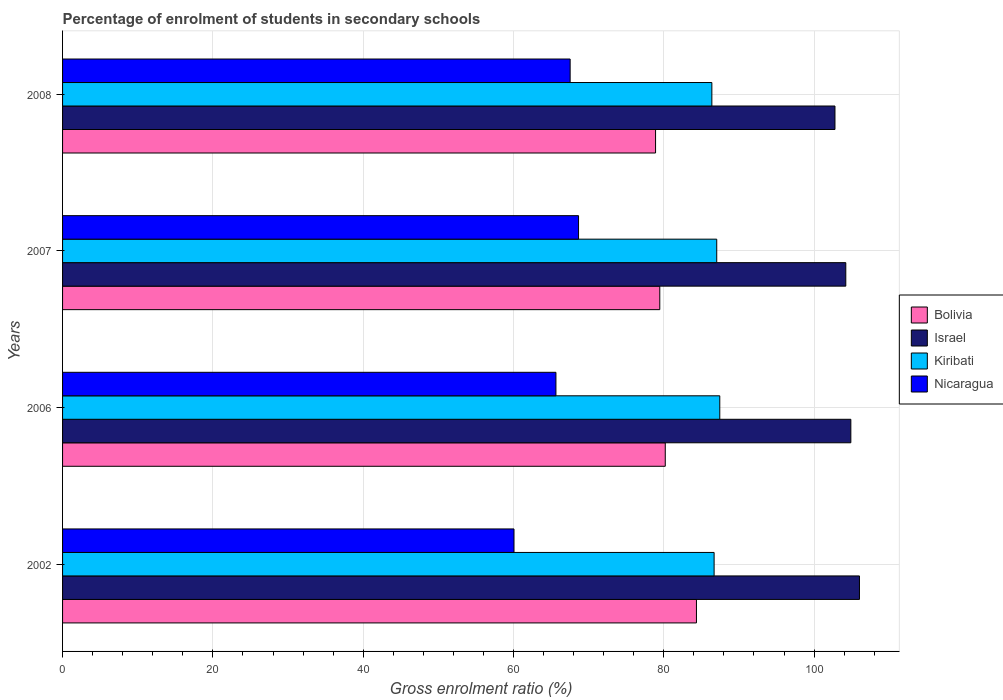Are the number of bars on each tick of the Y-axis equal?
Your answer should be very brief. Yes. What is the label of the 4th group of bars from the top?
Offer a very short reply. 2002. In how many cases, is the number of bars for a given year not equal to the number of legend labels?
Keep it short and to the point. 0. What is the percentage of students enrolled in secondary schools in Nicaragua in 2007?
Give a very brief answer. 68.66. Across all years, what is the maximum percentage of students enrolled in secondary schools in Bolivia?
Ensure brevity in your answer.  84.34. Across all years, what is the minimum percentage of students enrolled in secondary schools in Nicaragua?
Ensure brevity in your answer.  60.07. In which year was the percentage of students enrolled in secondary schools in Israel minimum?
Ensure brevity in your answer.  2008. What is the total percentage of students enrolled in secondary schools in Kiribati in the graph?
Make the answer very short. 347.58. What is the difference between the percentage of students enrolled in secondary schools in Bolivia in 2006 and that in 2007?
Ensure brevity in your answer.  0.73. What is the difference between the percentage of students enrolled in secondary schools in Bolivia in 2008 and the percentage of students enrolled in secondary schools in Nicaragua in 2007?
Make the answer very short. 10.25. What is the average percentage of students enrolled in secondary schools in Bolivia per year?
Provide a succinct answer. 80.73. In the year 2008, what is the difference between the percentage of students enrolled in secondary schools in Nicaragua and percentage of students enrolled in secondary schools in Kiribati?
Make the answer very short. -18.86. In how many years, is the percentage of students enrolled in secondary schools in Nicaragua greater than 52 %?
Offer a terse response. 4. What is the ratio of the percentage of students enrolled in secondary schools in Bolivia in 2002 to that in 2008?
Give a very brief answer. 1.07. Is the percentage of students enrolled in secondary schools in Nicaragua in 2006 less than that in 2007?
Your answer should be very brief. Yes. What is the difference between the highest and the second highest percentage of students enrolled in secondary schools in Israel?
Your answer should be very brief. 1.15. What is the difference between the highest and the lowest percentage of students enrolled in secondary schools in Israel?
Ensure brevity in your answer.  3.26. In how many years, is the percentage of students enrolled in secondary schools in Nicaragua greater than the average percentage of students enrolled in secondary schools in Nicaragua taken over all years?
Your answer should be very brief. 3. Is the sum of the percentage of students enrolled in secondary schools in Bolivia in 2007 and 2008 greater than the maximum percentage of students enrolled in secondary schools in Nicaragua across all years?
Your response must be concise. Yes. What does the 2nd bar from the top in 2006 represents?
Keep it short and to the point. Kiribati. What does the 4th bar from the bottom in 2008 represents?
Your answer should be very brief. Nicaragua. Is it the case that in every year, the sum of the percentage of students enrolled in secondary schools in Israel and percentage of students enrolled in secondary schools in Nicaragua is greater than the percentage of students enrolled in secondary schools in Kiribati?
Provide a succinct answer. Yes. How many bars are there?
Your response must be concise. 16. How many years are there in the graph?
Your answer should be compact. 4. Does the graph contain grids?
Keep it short and to the point. Yes. How many legend labels are there?
Your answer should be compact. 4. How are the legend labels stacked?
Provide a succinct answer. Vertical. What is the title of the graph?
Provide a succinct answer. Percentage of enrolment of students in secondary schools. Does "Guatemala" appear as one of the legend labels in the graph?
Give a very brief answer. No. What is the label or title of the X-axis?
Your answer should be very brief. Gross enrolment ratio (%). What is the label or title of the Y-axis?
Provide a short and direct response. Years. What is the Gross enrolment ratio (%) of Bolivia in 2002?
Ensure brevity in your answer.  84.34. What is the Gross enrolment ratio (%) of Israel in 2002?
Ensure brevity in your answer.  106.04. What is the Gross enrolment ratio (%) of Kiribati in 2002?
Your answer should be very brief. 86.69. What is the Gross enrolment ratio (%) in Nicaragua in 2002?
Make the answer very short. 60.07. What is the Gross enrolment ratio (%) of Bolivia in 2006?
Your answer should be compact. 80.2. What is the Gross enrolment ratio (%) in Israel in 2006?
Your answer should be compact. 104.89. What is the Gross enrolment ratio (%) in Kiribati in 2006?
Make the answer very short. 87.45. What is the Gross enrolment ratio (%) in Nicaragua in 2006?
Provide a short and direct response. 65.65. What is the Gross enrolment ratio (%) in Bolivia in 2007?
Make the answer very short. 79.47. What is the Gross enrolment ratio (%) in Israel in 2007?
Provide a succinct answer. 104.22. What is the Gross enrolment ratio (%) in Kiribati in 2007?
Give a very brief answer. 87.04. What is the Gross enrolment ratio (%) in Nicaragua in 2007?
Your answer should be very brief. 68.66. What is the Gross enrolment ratio (%) in Bolivia in 2008?
Make the answer very short. 78.9. What is the Gross enrolment ratio (%) in Israel in 2008?
Keep it short and to the point. 102.78. What is the Gross enrolment ratio (%) in Kiribati in 2008?
Offer a very short reply. 86.4. What is the Gross enrolment ratio (%) in Nicaragua in 2008?
Give a very brief answer. 67.54. Across all years, what is the maximum Gross enrolment ratio (%) in Bolivia?
Make the answer very short. 84.34. Across all years, what is the maximum Gross enrolment ratio (%) of Israel?
Provide a short and direct response. 106.04. Across all years, what is the maximum Gross enrolment ratio (%) of Kiribati?
Give a very brief answer. 87.45. Across all years, what is the maximum Gross enrolment ratio (%) in Nicaragua?
Keep it short and to the point. 68.66. Across all years, what is the minimum Gross enrolment ratio (%) in Bolivia?
Ensure brevity in your answer.  78.9. Across all years, what is the minimum Gross enrolment ratio (%) of Israel?
Give a very brief answer. 102.78. Across all years, what is the minimum Gross enrolment ratio (%) in Kiribati?
Your response must be concise. 86.4. Across all years, what is the minimum Gross enrolment ratio (%) of Nicaragua?
Provide a short and direct response. 60.07. What is the total Gross enrolment ratio (%) of Bolivia in the graph?
Your answer should be compact. 322.91. What is the total Gross enrolment ratio (%) of Israel in the graph?
Make the answer very short. 417.92. What is the total Gross enrolment ratio (%) in Kiribati in the graph?
Ensure brevity in your answer.  347.58. What is the total Gross enrolment ratio (%) in Nicaragua in the graph?
Ensure brevity in your answer.  261.91. What is the difference between the Gross enrolment ratio (%) of Bolivia in 2002 and that in 2006?
Keep it short and to the point. 4.15. What is the difference between the Gross enrolment ratio (%) of Israel in 2002 and that in 2006?
Your response must be concise. 1.15. What is the difference between the Gross enrolment ratio (%) in Kiribati in 2002 and that in 2006?
Ensure brevity in your answer.  -0.75. What is the difference between the Gross enrolment ratio (%) of Nicaragua in 2002 and that in 2006?
Your answer should be very brief. -5.58. What is the difference between the Gross enrolment ratio (%) in Bolivia in 2002 and that in 2007?
Your response must be concise. 4.88. What is the difference between the Gross enrolment ratio (%) in Israel in 2002 and that in 2007?
Ensure brevity in your answer.  1.82. What is the difference between the Gross enrolment ratio (%) of Kiribati in 2002 and that in 2007?
Make the answer very short. -0.35. What is the difference between the Gross enrolment ratio (%) of Nicaragua in 2002 and that in 2007?
Your response must be concise. -8.59. What is the difference between the Gross enrolment ratio (%) in Bolivia in 2002 and that in 2008?
Your response must be concise. 5.44. What is the difference between the Gross enrolment ratio (%) in Israel in 2002 and that in 2008?
Your answer should be compact. 3.26. What is the difference between the Gross enrolment ratio (%) of Kiribati in 2002 and that in 2008?
Provide a short and direct response. 0.3. What is the difference between the Gross enrolment ratio (%) in Nicaragua in 2002 and that in 2008?
Give a very brief answer. -7.47. What is the difference between the Gross enrolment ratio (%) in Bolivia in 2006 and that in 2007?
Ensure brevity in your answer.  0.73. What is the difference between the Gross enrolment ratio (%) in Israel in 2006 and that in 2007?
Provide a succinct answer. 0.67. What is the difference between the Gross enrolment ratio (%) in Kiribati in 2006 and that in 2007?
Offer a terse response. 0.41. What is the difference between the Gross enrolment ratio (%) in Nicaragua in 2006 and that in 2007?
Your answer should be very brief. -3.01. What is the difference between the Gross enrolment ratio (%) in Bolivia in 2006 and that in 2008?
Your response must be concise. 1.29. What is the difference between the Gross enrolment ratio (%) of Israel in 2006 and that in 2008?
Keep it short and to the point. 2.11. What is the difference between the Gross enrolment ratio (%) of Kiribati in 2006 and that in 2008?
Give a very brief answer. 1.05. What is the difference between the Gross enrolment ratio (%) of Nicaragua in 2006 and that in 2008?
Make the answer very short. -1.89. What is the difference between the Gross enrolment ratio (%) in Bolivia in 2007 and that in 2008?
Ensure brevity in your answer.  0.56. What is the difference between the Gross enrolment ratio (%) of Israel in 2007 and that in 2008?
Keep it short and to the point. 1.44. What is the difference between the Gross enrolment ratio (%) of Kiribati in 2007 and that in 2008?
Provide a short and direct response. 0.65. What is the difference between the Gross enrolment ratio (%) in Nicaragua in 2007 and that in 2008?
Offer a terse response. 1.12. What is the difference between the Gross enrolment ratio (%) of Bolivia in 2002 and the Gross enrolment ratio (%) of Israel in 2006?
Provide a short and direct response. -20.54. What is the difference between the Gross enrolment ratio (%) of Bolivia in 2002 and the Gross enrolment ratio (%) of Kiribati in 2006?
Provide a short and direct response. -3.1. What is the difference between the Gross enrolment ratio (%) of Bolivia in 2002 and the Gross enrolment ratio (%) of Nicaragua in 2006?
Make the answer very short. 18.7. What is the difference between the Gross enrolment ratio (%) in Israel in 2002 and the Gross enrolment ratio (%) in Kiribati in 2006?
Offer a very short reply. 18.59. What is the difference between the Gross enrolment ratio (%) in Israel in 2002 and the Gross enrolment ratio (%) in Nicaragua in 2006?
Provide a succinct answer. 40.39. What is the difference between the Gross enrolment ratio (%) of Kiribati in 2002 and the Gross enrolment ratio (%) of Nicaragua in 2006?
Provide a succinct answer. 21.05. What is the difference between the Gross enrolment ratio (%) of Bolivia in 2002 and the Gross enrolment ratio (%) of Israel in 2007?
Give a very brief answer. -19.87. What is the difference between the Gross enrolment ratio (%) of Bolivia in 2002 and the Gross enrolment ratio (%) of Kiribati in 2007?
Your answer should be compact. -2.7. What is the difference between the Gross enrolment ratio (%) of Bolivia in 2002 and the Gross enrolment ratio (%) of Nicaragua in 2007?
Provide a succinct answer. 15.69. What is the difference between the Gross enrolment ratio (%) of Israel in 2002 and the Gross enrolment ratio (%) of Kiribati in 2007?
Provide a short and direct response. 18.99. What is the difference between the Gross enrolment ratio (%) of Israel in 2002 and the Gross enrolment ratio (%) of Nicaragua in 2007?
Make the answer very short. 37.38. What is the difference between the Gross enrolment ratio (%) of Kiribati in 2002 and the Gross enrolment ratio (%) of Nicaragua in 2007?
Provide a short and direct response. 18.04. What is the difference between the Gross enrolment ratio (%) of Bolivia in 2002 and the Gross enrolment ratio (%) of Israel in 2008?
Your response must be concise. -18.43. What is the difference between the Gross enrolment ratio (%) of Bolivia in 2002 and the Gross enrolment ratio (%) of Kiribati in 2008?
Offer a terse response. -2.05. What is the difference between the Gross enrolment ratio (%) in Bolivia in 2002 and the Gross enrolment ratio (%) in Nicaragua in 2008?
Provide a succinct answer. 16.81. What is the difference between the Gross enrolment ratio (%) in Israel in 2002 and the Gross enrolment ratio (%) in Kiribati in 2008?
Your answer should be compact. 19.64. What is the difference between the Gross enrolment ratio (%) of Israel in 2002 and the Gross enrolment ratio (%) of Nicaragua in 2008?
Provide a short and direct response. 38.5. What is the difference between the Gross enrolment ratio (%) in Kiribati in 2002 and the Gross enrolment ratio (%) in Nicaragua in 2008?
Your answer should be very brief. 19.16. What is the difference between the Gross enrolment ratio (%) of Bolivia in 2006 and the Gross enrolment ratio (%) of Israel in 2007?
Your answer should be very brief. -24.02. What is the difference between the Gross enrolment ratio (%) in Bolivia in 2006 and the Gross enrolment ratio (%) in Kiribati in 2007?
Ensure brevity in your answer.  -6.85. What is the difference between the Gross enrolment ratio (%) of Bolivia in 2006 and the Gross enrolment ratio (%) of Nicaragua in 2007?
Keep it short and to the point. 11.54. What is the difference between the Gross enrolment ratio (%) of Israel in 2006 and the Gross enrolment ratio (%) of Kiribati in 2007?
Offer a terse response. 17.84. What is the difference between the Gross enrolment ratio (%) in Israel in 2006 and the Gross enrolment ratio (%) in Nicaragua in 2007?
Keep it short and to the point. 36.23. What is the difference between the Gross enrolment ratio (%) in Kiribati in 2006 and the Gross enrolment ratio (%) in Nicaragua in 2007?
Provide a succinct answer. 18.79. What is the difference between the Gross enrolment ratio (%) in Bolivia in 2006 and the Gross enrolment ratio (%) in Israel in 2008?
Offer a terse response. -22.58. What is the difference between the Gross enrolment ratio (%) of Bolivia in 2006 and the Gross enrolment ratio (%) of Kiribati in 2008?
Offer a terse response. -6.2. What is the difference between the Gross enrolment ratio (%) of Bolivia in 2006 and the Gross enrolment ratio (%) of Nicaragua in 2008?
Offer a very short reply. 12.66. What is the difference between the Gross enrolment ratio (%) in Israel in 2006 and the Gross enrolment ratio (%) in Kiribati in 2008?
Give a very brief answer. 18.49. What is the difference between the Gross enrolment ratio (%) of Israel in 2006 and the Gross enrolment ratio (%) of Nicaragua in 2008?
Make the answer very short. 37.35. What is the difference between the Gross enrolment ratio (%) of Kiribati in 2006 and the Gross enrolment ratio (%) of Nicaragua in 2008?
Ensure brevity in your answer.  19.91. What is the difference between the Gross enrolment ratio (%) of Bolivia in 2007 and the Gross enrolment ratio (%) of Israel in 2008?
Provide a short and direct response. -23.31. What is the difference between the Gross enrolment ratio (%) in Bolivia in 2007 and the Gross enrolment ratio (%) in Kiribati in 2008?
Give a very brief answer. -6.93. What is the difference between the Gross enrolment ratio (%) in Bolivia in 2007 and the Gross enrolment ratio (%) in Nicaragua in 2008?
Your answer should be very brief. 11.93. What is the difference between the Gross enrolment ratio (%) in Israel in 2007 and the Gross enrolment ratio (%) in Kiribati in 2008?
Provide a short and direct response. 17.82. What is the difference between the Gross enrolment ratio (%) in Israel in 2007 and the Gross enrolment ratio (%) in Nicaragua in 2008?
Provide a short and direct response. 36.68. What is the difference between the Gross enrolment ratio (%) of Kiribati in 2007 and the Gross enrolment ratio (%) of Nicaragua in 2008?
Make the answer very short. 19.51. What is the average Gross enrolment ratio (%) of Bolivia per year?
Offer a terse response. 80.73. What is the average Gross enrolment ratio (%) of Israel per year?
Offer a very short reply. 104.48. What is the average Gross enrolment ratio (%) of Kiribati per year?
Your response must be concise. 86.9. What is the average Gross enrolment ratio (%) of Nicaragua per year?
Offer a very short reply. 65.48. In the year 2002, what is the difference between the Gross enrolment ratio (%) of Bolivia and Gross enrolment ratio (%) of Israel?
Offer a very short reply. -21.69. In the year 2002, what is the difference between the Gross enrolment ratio (%) of Bolivia and Gross enrolment ratio (%) of Kiribati?
Offer a terse response. -2.35. In the year 2002, what is the difference between the Gross enrolment ratio (%) in Bolivia and Gross enrolment ratio (%) in Nicaragua?
Your answer should be compact. 24.28. In the year 2002, what is the difference between the Gross enrolment ratio (%) in Israel and Gross enrolment ratio (%) in Kiribati?
Offer a terse response. 19.34. In the year 2002, what is the difference between the Gross enrolment ratio (%) of Israel and Gross enrolment ratio (%) of Nicaragua?
Give a very brief answer. 45.97. In the year 2002, what is the difference between the Gross enrolment ratio (%) in Kiribati and Gross enrolment ratio (%) in Nicaragua?
Offer a very short reply. 26.63. In the year 2006, what is the difference between the Gross enrolment ratio (%) of Bolivia and Gross enrolment ratio (%) of Israel?
Make the answer very short. -24.69. In the year 2006, what is the difference between the Gross enrolment ratio (%) in Bolivia and Gross enrolment ratio (%) in Kiribati?
Provide a succinct answer. -7.25. In the year 2006, what is the difference between the Gross enrolment ratio (%) of Bolivia and Gross enrolment ratio (%) of Nicaragua?
Your answer should be very brief. 14.55. In the year 2006, what is the difference between the Gross enrolment ratio (%) in Israel and Gross enrolment ratio (%) in Kiribati?
Your answer should be compact. 17.44. In the year 2006, what is the difference between the Gross enrolment ratio (%) in Israel and Gross enrolment ratio (%) in Nicaragua?
Offer a very short reply. 39.24. In the year 2006, what is the difference between the Gross enrolment ratio (%) of Kiribati and Gross enrolment ratio (%) of Nicaragua?
Your answer should be compact. 21.8. In the year 2007, what is the difference between the Gross enrolment ratio (%) of Bolivia and Gross enrolment ratio (%) of Israel?
Provide a short and direct response. -24.75. In the year 2007, what is the difference between the Gross enrolment ratio (%) in Bolivia and Gross enrolment ratio (%) in Kiribati?
Keep it short and to the point. -7.58. In the year 2007, what is the difference between the Gross enrolment ratio (%) of Bolivia and Gross enrolment ratio (%) of Nicaragua?
Ensure brevity in your answer.  10.81. In the year 2007, what is the difference between the Gross enrolment ratio (%) of Israel and Gross enrolment ratio (%) of Kiribati?
Your answer should be compact. 17.17. In the year 2007, what is the difference between the Gross enrolment ratio (%) of Israel and Gross enrolment ratio (%) of Nicaragua?
Offer a very short reply. 35.56. In the year 2007, what is the difference between the Gross enrolment ratio (%) of Kiribati and Gross enrolment ratio (%) of Nicaragua?
Your answer should be very brief. 18.39. In the year 2008, what is the difference between the Gross enrolment ratio (%) of Bolivia and Gross enrolment ratio (%) of Israel?
Give a very brief answer. -23.87. In the year 2008, what is the difference between the Gross enrolment ratio (%) of Bolivia and Gross enrolment ratio (%) of Kiribati?
Your answer should be very brief. -7.49. In the year 2008, what is the difference between the Gross enrolment ratio (%) in Bolivia and Gross enrolment ratio (%) in Nicaragua?
Provide a short and direct response. 11.36. In the year 2008, what is the difference between the Gross enrolment ratio (%) in Israel and Gross enrolment ratio (%) in Kiribati?
Ensure brevity in your answer.  16.38. In the year 2008, what is the difference between the Gross enrolment ratio (%) of Israel and Gross enrolment ratio (%) of Nicaragua?
Provide a succinct answer. 35.24. In the year 2008, what is the difference between the Gross enrolment ratio (%) of Kiribati and Gross enrolment ratio (%) of Nicaragua?
Provide a short and direct response. 18.86. What is the ratio of the Gross enrolment ratio (%) in Bolivia in 2002 to that in 2006?
Give a very brief answer. 1.05. What is the ratio of the Gross enrolment ratio (%) in Israel in 2002 to that in 2006?
Offer a very short reply. 1.01. What is the ratio of the Gross enrolment ratio (%) in Nicaragua in 2002 to that in 2006?
Offer a terse response. 0.92. What is the ratio of the Gross enrolment ratio (%) of Bolivia in 2002 to that in 2007?
Your answer should be compact. 1.06. What is the ratio of the Gross enrolment ratio (%) of Israel in 2002 to that in 2007?
Keep it short and to the point. 1.02. What is the ratio of the Gross enrolment ratio (%) of Kiribati in 2002 to that in 2007?
Keep it short and to the point. 1. What is the ratio of the Gross enrolment ratio (%) of Nicaragua in 2002 to that in 2007?
Provide a short and direct response. 0.87. What is the ratio of the Gross enrolment ratio (%) in Bolivia in 2002 to that in 2008?
Your response must be concise. 1.07. What is the ratio of the Gross enrolment ratio (%) in Israel in 2002 to that in 2008?
Your answer should be compact. 1.03. What is the ratio of the Gross enrolment ratio (%) in Kiribati in 2002 to that in 2008?
Offer a terse response. 1. What is the ratio of the Gross enrolment ratio (%) in Nicaragua in 2002 to that in 2008?
Offer a terse response. 0.89. What is the ratio of the Gross enrolment ratio (%) in Bolivia in 2006 to that in 2007?
Provide a succinct answer. 1.01. What is the ratio of the Gross enrolment ratio (%) in Israel in 2006 to that in 2007?
Offer a terse response. 1.01. What is the ratio of the Gross enrolment ratio (%) in Nicaragua in 2006 to that in 2007?
Provide a short and direct response. 0.96. What is the ratio of the Gross enrolment ratio (%) of Bolivia in 2006 to that in 2008?
Ensure brevity in your answer.  1.02. What is the ratio of the Gross enrolment ratio (%) in Israel in 2006 to that in 2008?
Offer a terse response. 1.02. What is the ratio of the Gross enrolment ratio (%) in Kiribati in 2006 to that in 2008?
Make the answer very short. 1.01. What is the ratio of the Gross enrolment ratio (%) of Nicaragua in 2006 to that in 2008?
Provide a succinct answer. 0.97. What is the ratio of the Gross enrolment ratio (%) of Bolivia in 2007 to that in 2008?
Make the answer very short. 1.01. What is the ratio of the Gross enrolment ratio (%) of Israel in 2007 to that in 2008?
Your answer should be very brief. 1.01. What is the ratio of the Gross enrolment ratio (%) in Kiribati in 2007 to that in 2008?
Your answer should be compact. 1.01. What is the ratio of the Gross enrolment ratio (%) of Nicaragua in 2007 to that in 2008?
Give a very brief answer. 1.02. What is the difference between the highest and the second highest Gross enrolment ratio (%) of Bolivia?
Your response must be concise. 4.15. What is the difference between the highest and the second highest Gross enrolment ratio (%) of Israel?
Ensure brevity in your answer.  1.15. What is the difference between the highest and the second highest Gross enrolment ratio (%) of Kiribati?
Offer a very short reply. 0.41. What is the difference between the highest and the second highest Gross enrolment ratio (%) in Nicaragua?
Provide a short and direct response. 1.12. What is the difference between the highest and the lowest Gross enrolment ratio (%) in Bolivia?
Keep it short and to the point. 5.44. What is the difference between the highest and the lowest Gross enrolment ratio (%) of Israel?
Offer a very short reply. 3.26. What is the difference between the highest and the lowest Gross enrolment ratio (%) in Kiribati?
Your answer should be compact. 1.05. What is the difference between the highest and the lowest Gross enrolment ratio (%) of Nicaragua?
Offer a very short reply. 8.59. 